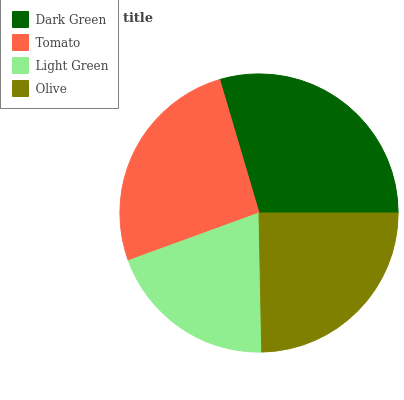Is Light Green the minimum?
Answer yes or no. Yes. Is Dark Green the maximum?
Answer yes or no. Yes. Is Tomato the minimum?
Answer yes or no. No. Is Tomato the maximum?
Answer yes or no. No. Is Dark Green greater than Tomato?
Answer yes or no. Yes. Is Tomato less than Dark Green?
Answer yes or no. Yes. Is Tomato greater than Dark Green?
Answer yes or no. No. Is Dark Green less than Tomato?
Answer yes or no. No. Is Tomato the high median?
Answer yes or no. Yes. Is Olive the low median?
Answer yes or no. Yes. Is Light Green the high median?
Answer yes or no. No. Is Light Green the low median?
Answer yes or no. No. 